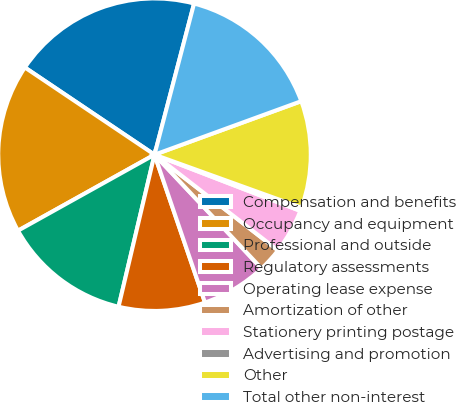Convert chart to OTSL. <chart><loc_0><loc_0><loc_500><loc_500><pie_chart><fcel>Compensation and benefits<fcel>Occupancy and equipment<fcel>Professional and outside<fcel>Regulatory assessments<fcel>Operating lease expense<fcel>Amortization of other<fcel>Stationery printing postage<fcel>Advertising and promotion<fcel>Other<fcel>Total other non-interest<nl><fcel>19.65%<fcel>17.51%<fcel>13.22%<fcel>8.93%<fcel>6.78%<fcel>2.49%<fcel>4.64%<fcel>0.35%<fcel>11.07%<fcel>15.36%<nl></chart> 